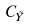<formula> <loc_0><loc_0><loc_500><loc_500>C _ { \tilde { Y } }</formula> 